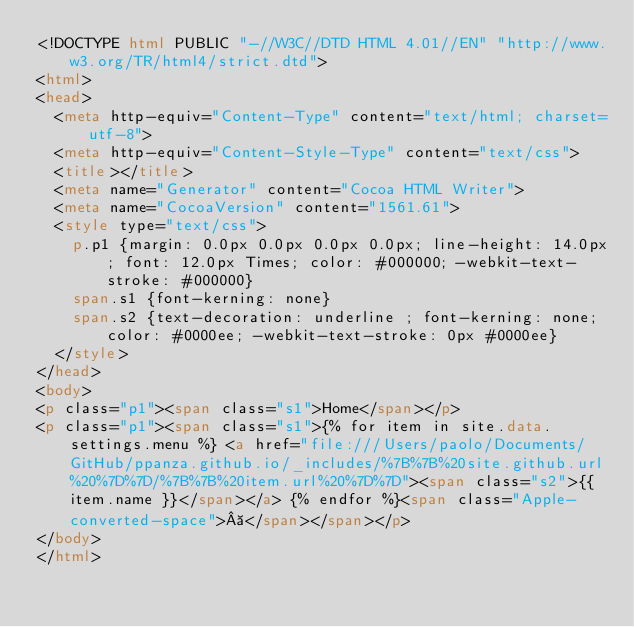Convert code to text. <code><loc_0><loc_0><loc_500><loc_500><_HTML_><!DOCTYPE html PUBLIC "-//W3C//DTD HTML 4.01//EN" "http://www.w3.org/TR/html4/strict.dtd">
<html>
<head>
  <meta http-equiv="Content-Type" content="text/html; charset=utf-8">
  <meta http-equiv="Content-Style-Type" content="text/css">
  <title></title>
  <meta name="Generator" content="Cocoa HTML Writer">
  <meta name="CocoaVersion" content="1561.61">
  <style type="text/css">
    p.p1 {margin: 0.0px 0.0px 0.0px 0.0px; line-height: 14.0px; font: 12.0px Times; color: #000000; -webkit-text-stroke: #000000}
    span.s1 {font-kerning: none}
    span.s2 {text-decoration: underline ; font-kerning: none; color: #0000ee; -webkit-text-stroke: 0px #0000ee}
  </style>
</head>
<body>
<p class="p1"><span class="s1">Home</span></p>
<p class="p1"><span class="s1">{% for item in site.data.settings.menu %} <a href="file:///Users/paolo/Documents/GitHub/ppanza.github.io/_includes/%7B%7B%20site.github.url%20%7D%7D/%7B%7B%20item.url%20%7D%7D"><span class="s2">{{ item.name }}</span></a> {% endfor %}<span class="Apple-converted-space"> </span></span></p>
</body>
</html>
</code> 